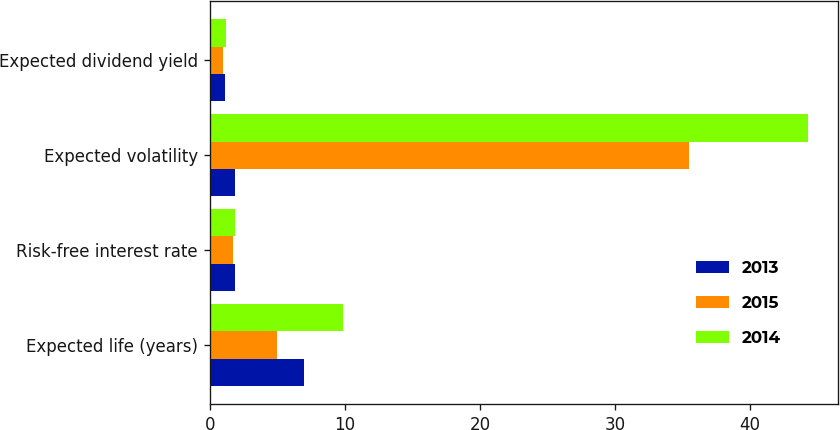Convert chart to OTSL. <chart><loc_0><loc_0><loc_500><loc_500><stacked_bar_chart><ecel><fcel>Expected life (years)<fcel>Risk-free interest rate<fcel>Expected volatility<fcel>Expected dividend yield<nl><fcel>2013<fcel>7<fcel>1.9<fcel>1.9<fcel>1.1<nl><fcel>2015<fcel>5<fcel>1.7<fcel>35.5<fcel>1<nl><fcel>2014<fcel>9.9<fcel>1.9<fcel>44.3<fcel>1.2<nl></chart> 